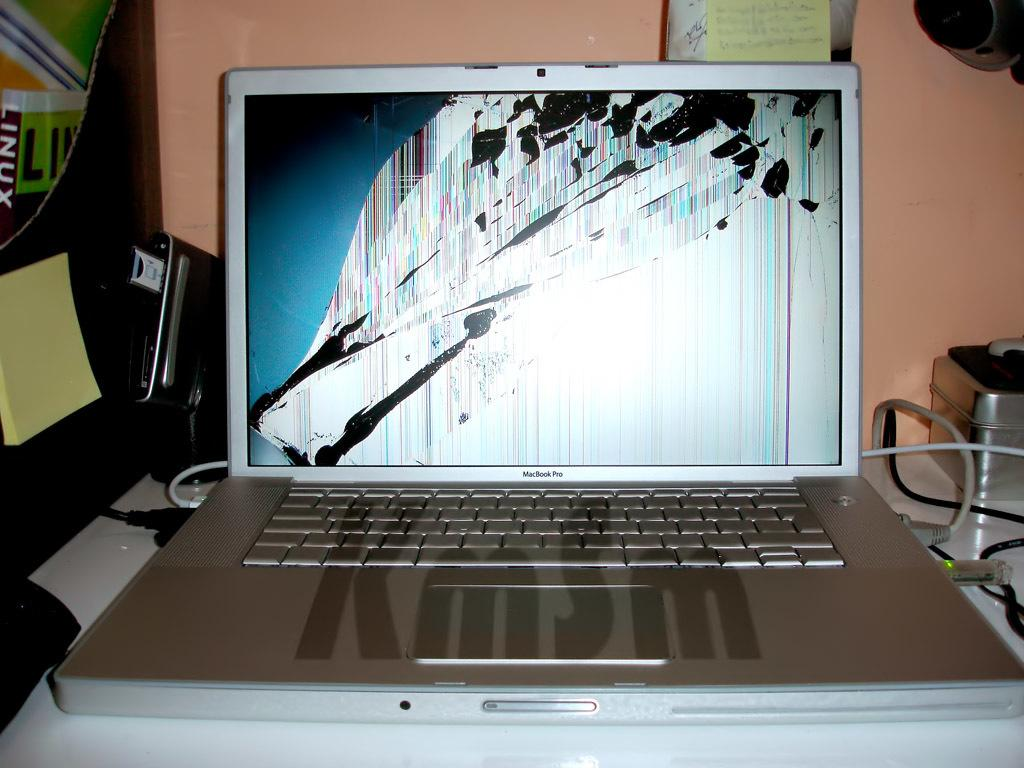<image>
Give a short and clear explanation of the subsequent image. The MacBook Pro has the letters KmSm across the keyboard. 